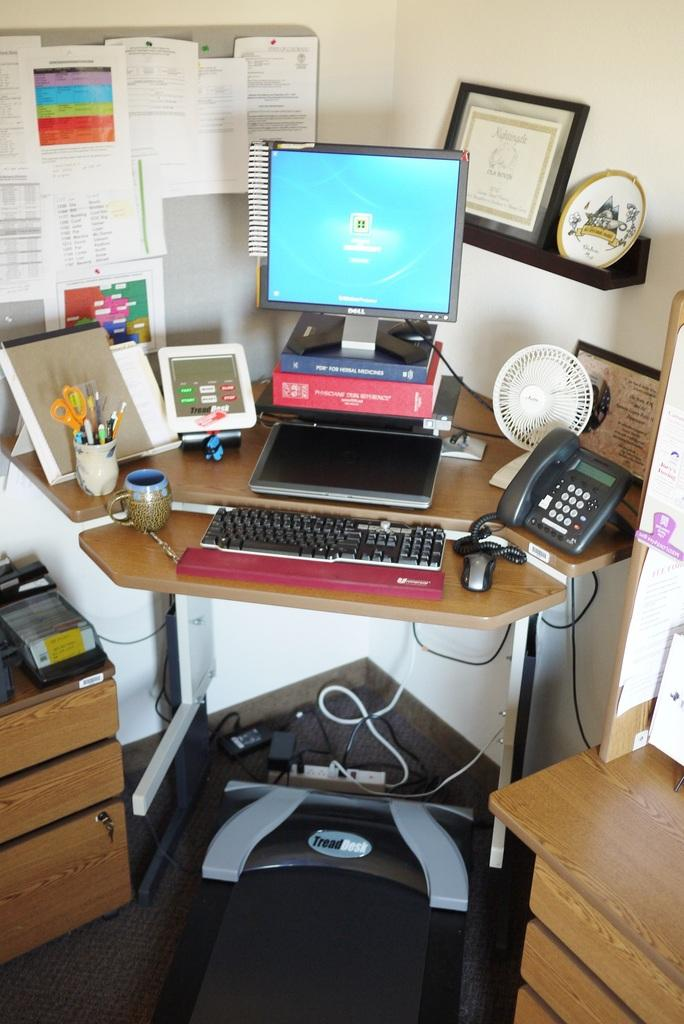What type of furniture is in the image? There is a table in the image. What is on top of the table? The table has a desktop on it, along with books, a keyboard, and a mouse. Are there any other objects on the table? Yes, there are other objects on the table. Are there any objects placed beside the table? Yes, there are additional objects placed beside the table. Can you see any hills in the image? There are no hills visible in the image; it features a table with various objects on and around it. 